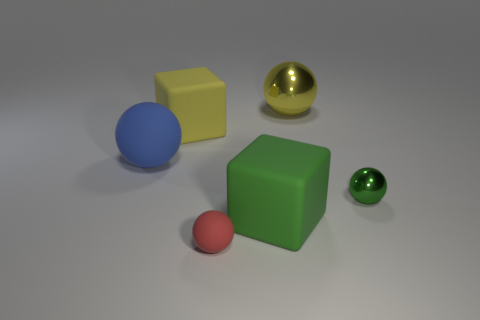Can you tell me if there are any patterns or engravings on any of the objects? From the image provided, there do not appear to be any patterns or engravings on the objects; they all have solid, uniform colors. 